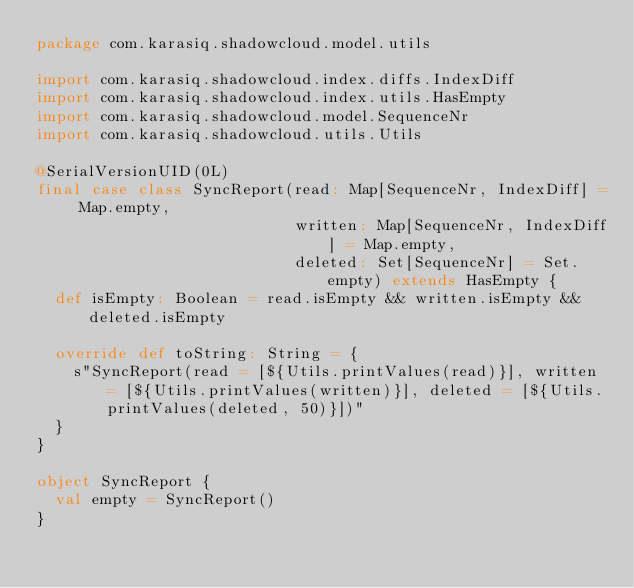<code> <loc_0><loc_0><loc_500><loc_500><_Scala_>package com.karasiq.shadowcloud.model.utils

import com.karasiq.shadowcloud.index.diffs.IndexDiff
import com.karasiq.shadowcloud.index.utils.HasEmpty
import com.karasiq.shadowcloud.model.SequenceNr
import com.karasiq.shadowcloud.utils.Utils

@SerialVersionUID(0L)
final case class SyncReport(read: Map[SequenceNr, IndexDiff] = Map.empty,
                            written: Map[SequenceNr, IndexDiff] = Map.empty,
                            deleted: Set[SequenceNr] = Set.empty) extends HasEmpty {
  def isEmpty: Boolean = read.isEmpty && written.isEmpty && deleted.isEmpty

  override def toString: String = {
    s"SyncReport(read = [${Utils.printValues(read)}], written = [${Utils.printValues(written)}], deleted = [${Utils.printValues(deleted, 50)}])"
  }
}

object SyncReport {
  val empty = SyncReport()
}
</code> 